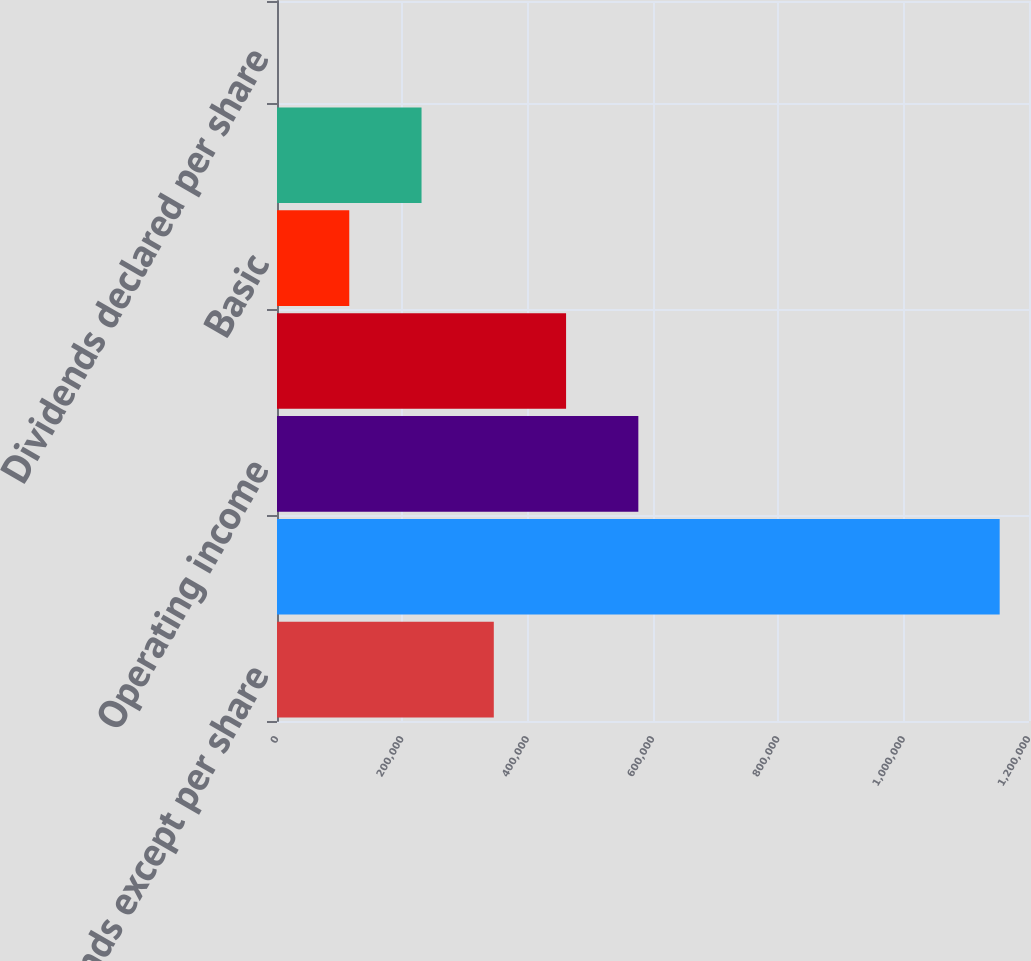<chart> <loc_0><loc_0><loc_500><loc_500><bar_chart><fcel>(in thousands except per share<fcel>Total revenues 1<fcel>Operating income<fcel>Net income (loss)<fcel>Basic<fcel>Diluted<fcel>Dividends declared per share<nl><fcel>345965<fcel>1.15322e+06<fcel>576608<fcel>461286<fcel>115322<fcel>230643<fcel>0.15<nl></chart> 